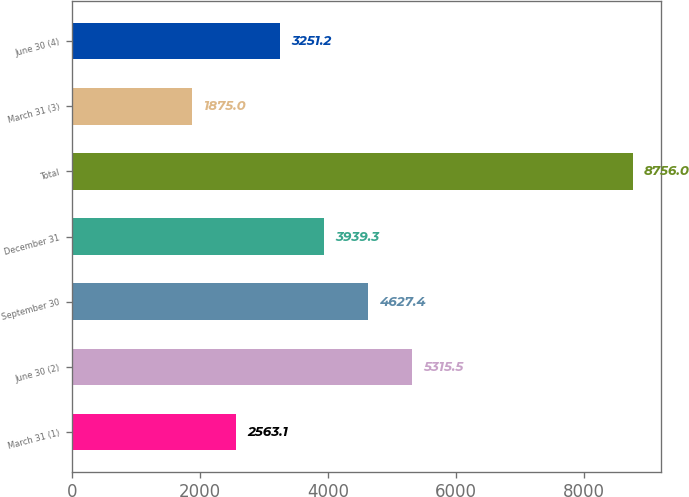Convert chart to OTSL. <chart><loc_0><loc_0><loc_500><loc_500><bar_chart><fcel>March 31 (1)<fcel>June 30 (2)<fcel>September 30<fcel>December 31<fcel>Total<fcel>March 31 (3)<fcel>June 30 (4)<nl><fcel>2563.1<fcel>5315.5<fcel>4627.4<fcel>3939.3<fcel>8756<fcel>1875<fcel>3251.2<nl></chart> 